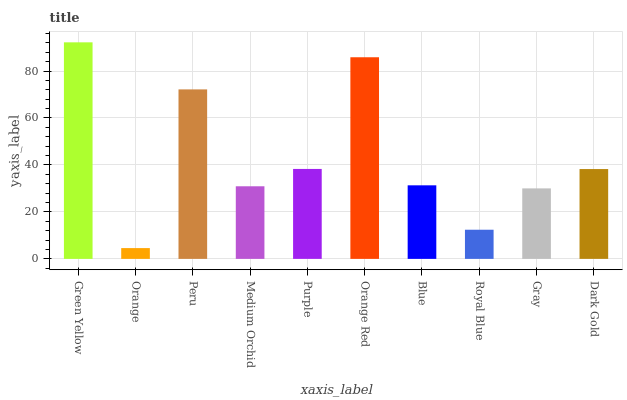Is Peru the minimum?
Answer yes or no. No. Is Peru the maximum?
Answer yes or no. No. Is Peru greater than Orange?
Answer yes or no. Yes. Is Orange less than Peru?
Answer yes or no. Yes. Is Orange greater than Peru?
Answer yes or no. No. Is Peru less than Orange?
Answer yes or no. No. Is Dark Gold the high median?
Answer yes or no. Yes. Is Blue the low median?
Answer yes or no. Yes. Is Orange the high median?
Answer yes or no. No. Is Peru the low median?
Answer yes or no. No. 